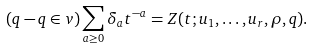<formula> <loc_0><loc_0><loc_500><loc_500>( q - q \in v ) \sum _ { a \geq 0 } \delta _ { a } t ^ { - a } = Z ( t ; u _ { 1 } , \dots , u _ { r } , \rho , q ) .</formula> 